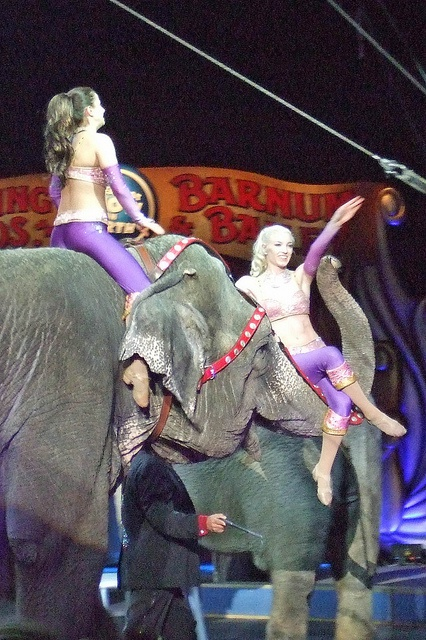Describe the objects in this image and their specific colors. I can see elephant in black, gray, and darkgray tones, elephant in black, gray, and darkgray tones, people in black, gray, and darkblue tones, people in black, white, darkgray, violet, and gray tones, and people in black, white, tan, and violet tones in this image. 